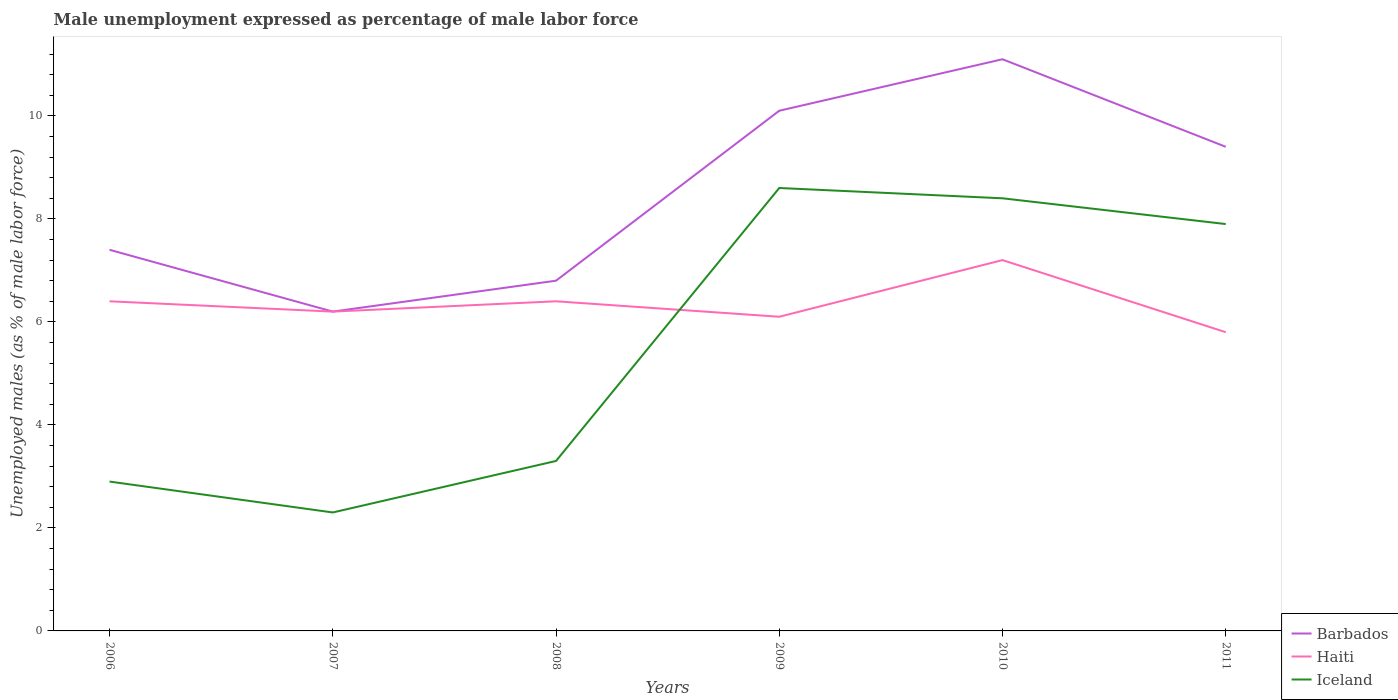How many different coloured lines are there?
Make the answer very short. 3. Does the line corresponding to Barbados intersect with the line corresponding to Haiti?
Your answer should be compact. Yes. Across all years, what is the maximum unemployment in males in in Haiti?
Give a very brief answer. 5.8. In which year was the unemployment in males in in Barbados maximum?
Give a very brief answer. 2007. What is the total unemployment in males in in Iceland in the graph?
Make the answer very short. 0.7. What is the difference between the highest and the second highest unemployment in males in in Haiti?
Provide a succinct answer. 1.4. What is the difference between the highest and the lowest unemployment in males in in Barbados?
Give a very brief answer. 3. How many years are there in the graph?
Provide a short and direct response. 6. What is the difference between two consecutive major ticks on the Y-axis?
Make the answer very short. 2. Are the values on the major ticks of Y-axis written in scientific E-notation?
Your response must be concise. No. Does the graph contain any zero values?
Make the answer very short. No. Where does the legend appear in the graph?
Make the answer very short. Bottom right. How many legend labels are there?
Ensure brevity in your answer.  3. What is the title of the graph?
Make the answer very short. Male unemployment expressed as percentage of male labor force. Does "Sierra Leone" appear as one of the legend labels in the graph?
Provide a short and direct response. No. What is the label or title of the X-axis?
Your answer should be very brief. Years. What is the label or title of the Y-axis?
Your answer should be compact. Unemployed males (as % of male labor force). What is the Unemployed males (as % of male labor force) in Barbados in 2006?
Make the answer very short. 7.4. What is the Unemployed males (as % of male labor force) of Haiti in 2006?
Provide a short and direct response. 6.4. What is the Unemployed males (as % of male labor force) in Iceland in 2006?
Provide a succinct answer. 2.9. What is the Unemployed males (as % of male labor force) in Barbados in 2007?
Your response must be concise. 6.2. What is the Unemployed males (as % of male labor force) in Haiti in 2007?
Your answer should be compact. 6.2. What is the Unemployed males (as % of male labor force) of Iceland in 2007?
Offer a very short reply. 2.3. What is the Unemployed males (as % of male labor force) of Barbados in 2008?
Offer a terse response. 6.8. What is the Unemployed males (as % of male labor force) of Haiti in 2008?
Ensure brevity in your answer.  6.4. What is the Unemployed males (as % of male labor force) in Iceland in 2008?
Provide a succinct answer. 3.3. What is the Unemployed males (as % of male labor force) of Barbados in 2009?
Your answer should be very brief. 10.1. What is the Unemployed males (as % of male labor force) in Haiti in 2009?
Your answer should be very brief. 6.1. What is the Unemployed males (as % of male labor force) of Iceland in 2009?
Give a very brief answer. 8.6. What is the Unemployed males (as % of male labor force) of Barbados in 2010?
Make the answer very short. 11.1. What is the Unemployed males (as % of male labor force) in Haiti in 2010?
Your response must be concise. 7.2. What is the Unemployed males (as % of male labor force) in Iceland in 2010?
Your answer should be very brief. 8.4. What is the Unemployed males (as % of male labor force) of Barbados in 2011?
Offer a terse response. 9.4. What is the Unemployed males (as % of male labor force) in Haiti in 2011?
Your answer should be very brief. 5.8. What is the Unemployed males (as % of male labor force) in Iceland in 2011?
Offer a very short reply. 7.9. Across all years, what is the maximum Unemployed males (as % of male labor force) of Barbados?
Make the answer very short. 11.1. Across all years, what is the maximum Unemployed males (as % of male labor force) of Haiti?
Offer a very short reply. 7.2. Across all years, what is the maximum Unemployed males (as % of male labor force) in Iceland?
Your answer should be compact. 8.6. Across all years, what is the minimum Unemployed males (as % of male labor force) in Barbados?
Your answer should be compact. 6.2. Across all years, what is the minimum Unemployed males (as % of male labor force) of Haiti?
Your answer should be compact. 5.8. Across all years, what is the minimum Unemployed males (as % of male labor force) in Iceland?
Provide a succinct answer. 2.3. What is the total Unemployed males (as % of male labor force) of Haiti in the graph?
Keep it short and to the point. 38.1. What is the total Unemployed males (as % of male labor force) of Iceland in the graph?
Offer a very short reply. 33.4. What is the difference between the Unemployed males (as % of male labor force) of Barbados in 2006 and that in 2007?
Ensure brevity in your answer.  1.2. What is the difference between the Unemployed males (as % of male labor force) of Iceland in 2006 and that in 2008?
Offer a terse response. -0.4. What is the difference between the Unemployed males (as % of male labor force) in Barbados in 2006 and that in 2009?
Offer a very short reply. -2.7. What is the difference between the Unemployed males (as % of male labor force) of Haiti in 2006 and that in 2009?
Your response must be concise. 0.3. What is the difference between the Unemployed males (as % of male labor force) in Iceland in 2006 and that in 2010?
Make the answer very short. -5.5. What is the difference between the Unemployed males (as % of male labor force) in Barbados in 2006 and that in 2011?
Make the answer very short. -2. What is the difference between the Unemployed males (as % of male labor force) in Haiti in 2006 and that in 2011?
Your answer should be compact. 0.6. What is the difference between the Unemployed males (as % of male labor force) in Iceland in 2006 and that in 2011?
Keep it short and to the point. -5. What is the difference between the Unemployed males (as % of male labor force) in Iceland in 2007 and that in 2009?
Your response must be concise. -6.3. What is the difference between the Unemployed males (as % of male labor force) of Barbados in 2007 and that in 2010?
Offer a very short reply. -4.9. What is the difference between the Unemployed males (as % of male labor force) of Haiti in 2007 and that in 2010?
Provide a succinct answer. -1. What is the difference between the Unemployed males (as % of male labor force) of Iceland in 2007 and that in 2010?
Provide a short and direct response. -6.1. What is the difference between the Unemployed males (as % of male labor force) in Barbados in 2007 and that in 2011?
Keep it short and to the point. -3.2. What is the difference between the Unemployed males (as % of male labor force) in Haiti in 2007 and that in 2011?
Provide a succinct answer. 0.4. What is the difference between the Unemployed males (as % of male labor force) in Iceland in 2007 and that in 2011?
Your answer should be compact. -5.6. What is the difference between the Unemployed males (as % of male labor force) of Barbados in 2008 and that in 2009?
Ensure brevity in your answer.  -3.3. What is the difference between the Unemployed males (as % of male labor force) in Haiti in 2008 and that in 2009?
Make the answer very short. 0.3. What is the difference between the Unemployed males (as % of male labor force) in Haiti in 2008 and that in 2010?
Give a very brief answer. -0.8. What is the difference between the Unemployed males (as % of male labor force) of Iceland in 2008 and that in 2010?
Make the answer very short. -5.1. What is the difference between the Unemployed males (as % of male labor force) of Iceland in 2008 and that in 2011?
Give a very brief answer. -4.6. What is the difference between the Unemployed males (as % of male labor force) in Iceland in 2009 and that in 2010?
Your answer should be very brief. 0.2. What is the difference between the Unemployed males (as % of male labor force) of Barbados in 2009 and that in 2011?
Provide a succinct answer. 0.7. What is the difference between the Unemployed males (as % of male labor force) in Haiti in 2009 and that in 2011?
Your answer should be very brief. 0.3. What is the difference between the Unemployed males (as % of male labor force) in Barbados in 2006 and the Unemployed males (as % of male labor force) in Iceland in 2007?
Your answer should be compact. 5.1. What is the difference between the Unemployed males (as % of male labor force) in Haiti in 2006 and the Unemployed males (as % of male labor force) in Iceland in 2007?
Offer a very short reply. 4.1. What is the difference between the Unemployed males (as % of male labor force) in Barbados in 2006 and the Unemployed males (as % of male labor force) in Haiti in 2008?
Your response must be concise. 1. What is the difference between the Unemployed males (as % of male labor force) in Barbados in 2006 and the Unemployed males (as % of male labor force) in Iceland in 2008?
Your response must be concise. 4.1. What is the difference between the Unemployed males (as % of male labor force) in Barbados in 2006 and the Unemployed males (as % of male labor force) in Haiti in 2010?
Make the answer very short. 0.2. What is the difference between the Unemployed males (as % of male labor force) of Barbados in 2006 and the Unemployed males (as % of male labor force) of Iceland in 2010?
Your answer should be compact. -1. What is the difference between the Unemployed males (as % of male labor force) of Barbados in 2006 and the Unemployed males (as % of male labor force) of Haiti in 2011?
Offer a terse response. 1.6. What is the difference between the Unemployed males (as % of male labor force) in Barbados in 2006 and the Unemployed males (as % of male labor force) in Iceland in 2011?
Offer a very short reply. -0.5. What is the difference between the Unemployed males (as % of male labor force) of Barbados in 2007 and the Unemployed males (as % of male labor force) of Haiti in 2009?
Offer a very short reply. 0.1. What is the difference between the Unemployed males (as % of male labor force) in Barbados in 2007 and the Unemployed males (as % of male labor force) in Iceland in 2009?
Your answer should be very brief. -2.4. What is the difference between the Unemployed males (as % of male labor force) of Haiti in 2007 and the Unemployed males (as % of male labor force) of Iceland in 2009?
Offer a very short reply. -2.4. What is the difference between the Unemployed males (as % of male labor force) of Barbados in 2007 and the Unemployed males (as % of male labor force) of Iceland in 2011?
Your response must be concise. -1.7. What is the difference between the Unemployed males (as % of male labor force) of Barbados in 2008 and the Unemployed males (as % of male labor force) of Iceland in 2009?
Give a very brief answer. -1.8. What is the difference between the Unemployed males (as % of male labor force) of Haiti in 2008 and the Unemployed males (as % of male labor force) of Iceland in 2009?
Your answer should be compact. -2.2. What is the difference between the Unemployed males (as % of male labor force) of Barbados in 2008 and the Unemployed males (as % of male labor force) of Haiti in 2010?
Make the answer very short. -0.4. What is the difference between the Unemployed males (as % of male labor force) in Barbados in 2008 and the Unemployed males (as % of male labor force) in Iceland in 2010?
Your answer should be very brief. -1.6. What is the difference between the Unemployed males (as % of male labor force) in Haiti in 2008 and the Unemployed males (as % of male labor force) in Iceland in 2010?
Make the answer very short. -2. What is the difference between the Unemployed males (as % of male labor force) in Barbados in 2008 and the Unemployed males (as % of male labor force) in Haiti in 2011?
Your response must be concise. 1. What is the difference between the Unemployed males (as % of male labor force) in Barbados in 2008 and the Unemployed males (as % of male labor force) in Iceland in 2011?
Offer a very short reply. -1.1. What is the difference between the Unemployed males (as % of male labor force) of Haiti in 2008 and the Unemployed males (as % of male labor force) of Iceland in 2011?
Keep it short and to the point. -1.5. What is the difference between the Unemployed males (as % of male labor force) of Barbados in 2009 and the Unemployed males (as % of male labor force) of Iceland in 2011?
Your response must be concise. 2.2. What is the difference between the Unemployed males (as % of male labor force) of Barbados in 2010 and the Unemployed males (as % of male labor force) of Iceland in 2011?
Your answer should be compact. 3.2. What is the difference between the Unemployed males (as % of male labor force) in Haiti in 2010 and the Unemployed males (as % of male labor force) in Iceland in 2011?
Make the answer very short. -0.7. What is the average Unemployed males (as % of male labor force) of Haiti per year?
Give a very brief answer. 6.35. What is the average Unemployed males (as % of male labor force) of Iceland per year?
Your answer should be very brief. 5.57. In the year 2006, what is the difference between the Unemployed males (as % of male labor force) of Barbados and Unemployed males (as % of male labor force) of Haiti?
Your answer should be very brief. 1. In the year 2006, what is the difference between the Unemployed males (as % of male labor force) in Barbados and Unemployed males (as % of male labor force) in Iceland?
Make the answer very short. 4.5. In the year 2007, what is the difference between the Unemployed males (as % of male labor force) in Barbados and Unemployed males (as % of male labor force) in Iceland?
Your response must be concise. 3.9. In the year 2008, what is the difference between the Unemployed males (as % of male labor force) of Barbados and Unemployed males (as % of male labor force) of Haiti?
Provide a short and direct response. 0.4. In the year 2009, what is the difference between the Unemployed males (as % of male labor force) in Barbados and Unemployed males (as % of male labor force) in Haiti?
Your response must be concise. 4. In the year 2009, what is the difference between the Unemployed males (as % of male labor force) in Barbados and Unemployed males (as % of male labor force) in Iceland?
Offer a terse response. 1.5. In the year 2009, what is the difference between the Unemployed males (as % of male labor force) in Haiti and Unemployed males (as % of male labor force) in Iceland?
Make the answer very short. -2.5. In the year 2010, what is the difference between the Unemployed males (as % of male labor force) of Barbados and Unemployed males (as % of male labor force) of Haiti?
Ensure brevity in your answer.  3.9. In the year 2010, what is the difference between the Unemployed males (as % of male labor force) of Barbados and Unemployed males (as % of male labor force) of Iceland?
Provide a succinct answer. 2.7. In the year 2010, what is the difference between the Unemployed males (as % of male labor force) in Haiti and Unemployed males (as % of male labor force) in Iceland?
Provide a succinct answer. -1.2. In the year 2011, what is the difference between the Unemployed males (as % of male labor force) in Barbados and Unemployed males (as % of male labor force) in Haiti?
Make the answer very short. 3.6. What is the ratio of the Unemployed males (as % of male labor force) of Barbados in 2006 to that in 2007?
Keep it short and to the point. 1.19. What is the ratio of the Unemployed males (as % of male labor force) of Haiti in 2006 to that in 2007?
Your response must be concise. 1.03. What is the ratio of the Unemployed males (as % of male labor force) in Iceland in 2006 to that in 2007?
Give a very brief answer. 1.26. What is the ratio of the Unemployed males (as % of male labor force) in Barbados in 2006 to that in 2008?
Your answer should be compact. 1.09. What is the ratio of the Unemployed males (as % of male labor force) in Iceland in 2006 to that in 2008?
Provide a succinct answer. 0.88. What is the ratio of the Unemployed males (as % of male labor force) of Barbados in 2006 to that in 2009?
Ensure brevity in your answer.  0.73. What is the ratio of the Unemployed males (as % of male labor force) in Haiti in 2006 to that in 2009?
Make the answer very short. 1.05. What is the ratio of the Unemployed males (as % of male labor force) of Iceland in 2006 to that in 2009?
Ensure brevity in your answer.  0.34. What is the ratio of the Unemployed males (as % of male labor force) of Barbados in 2006 to that in 2010?
Your answer should be very brief. 0.67. What is the ratio of the Unemployed males (as % of male labor force) of Iceland in 2006 to that in 2010?
Ensure brevity in your answer.  0.35. What is the ratio of the Unemployed males (as % of male labor force) in Barbados in 2006 to that in 2011?
Offer a terse response. 0.79. What is the ratio of the Unemployed males (as % of male labor force) in Haiti in 2006 to that in 2011?
Make the answer very short. 1.1. What is the ratio of the Unemployed males (as % of male labor force) of Iceland in 2006 to that in 2011?
Ensure brevity in your answer.  0.37. What is the ratio of the Unemployed males (as % of male labor force) in Barbados in 2007 to that in 2008?
Offer a very short reply. 0.91. What is the ratio of the Unemployed males (as % of male labor force) in Haiti in 2007 to that in 2008?
Provide a succinct answer. 0.97. What is the ratio of the Unemployed males (as % of male labor force) in Iceland in 2007 to that in 2008?
Offer a terse response. 0.7. What is the ratio of the Unemployed males (as % of male labor force) in Barbados in 2007 to that in 2009?
Provide a succinct answer. 0.61. What is the ratio of the Unemployed males (as % of male labor force) in Haiti in 2007 to that in 2009?
Keep it short and to the point. 1.02. What is the ratio of the Unemployed males (as % of male labor force) in Iceland in 2007 to that in 2009?
Your response must be concise. 0.27. What is the ratio of the Unemployed males (as % of male labor force) in Barbados in 2007 to that in 2010?
Your response must be concise. 0.56. What is the ratio of the Unemployed males (as % of male labor force) in Haiti in 2007 to that in 2010?
Offer a very short reply. 0.86. What is the ratio of the Unemployed males (as % of male labor force) in Iceland in 2007 to that in 2010?
Make the answer very short. 0.27. What is the ratio of the Unemployed males (as % of male labor force) of Barbados in 2007 to that in 2011?
Keep it short and to the point. 0.66. What is the ratio of the Unemployed males (as % of male labor force) of Haiti in 2007 to that in 2011?
Keep it short and to the point. 1.07. What is the ratio of the Unemployed males (as % of male labor force) of Iceland in 2007 to that in 2011?
Your response must be concise. 0.29. What is the ratio of the Unemployed males (as % of male labor force) in Barbados in 2008 to that in 2009?
Provide a succinct answer. 0.67. What is the ratio of the Unemployed males (as % of male labor force) of Haiti in 2008 to that in 2009?
Give a very brief answer. 1.05. What is the ratio of the Unemployed males (as % of male labor force) in Iceland in 2008 to that in 2009?
Your answer should be very brief. 0.38. What is the ratio of the Unemployed males (as % of male labor force) in Barbados in 2008 to that in 2010?
Provide a succinct answer. 0.61. What is the ratio of the Unemployed males (as % of male labor force) of Iceland in 2008 to that in 2010?
Give a very brief answer. 0.39. What is the ratio of the Unemployed males (as % of male labor force) in Barbados in 2008 to that in 2011?
Keep it short and to the point. 0.72. What is the ratio of the Unemployed males (as % of male labor force) of Haiti in 2008 to that in 2011?
Give a very brief answer. 1.1. What is the ratio of the Unemployed males (as % of male labor force) in Iceland in 2008 to that in 2011?
Offer a terse response. 0.42. What is the ratio of the Unemployed males (as % of male labor force) in Barbados in 2009 to that in 2010?
Provide a short and direct response. 0.91. What is the ratio of the Unemployed males (as % of male labor force) of Haiti in 2009 to that in 2010?
Your answer should be compact. 0.85. What is the ratio of the Unemployed males (as % of male labor force) in Iceland in 2009 to that in 2010?
Your answer should be compact. 1.02. What is the ratio of the Unemployed males (as % of male labor force) in Barbados in 2009 to that in 2011?
Ensure brevity in your answer.  1.07. What is the ratio of the Unemployed males (as % of male labor force) of Haiti in 2009 to that in 2011?
Give a very brief answer. 1.05. What is the ratio of the Unemployed males (as % of male labor force) of Iceland in 2009 to that in 2011?
Your answer should be compact. 1.09. What is the ratio of the Unemployed males (as % of male labor force) in Barbados in 2010 to that in 2011?
Provide a succinct answer. 1.18. What is the ratio of the Unemployed males (as % of male labor force) in Haiti in 2010 to that in 2011?
Provide a short and direct response. 1.24. What is the ratio of the Unemployed males (as % of male labor force) in Iceland in 2010 to that in 2011?
Your response must be concise. 1.06. What is the difference between the highest and the second highest Unemployed males (as % of male labor force) of Haiti?
Give a very brief answer. 0.8. What is the difference between the highest and the lowest Unemployed males (as % of male labor force) in Iceland?
Your answer should be compact. 6.3. 